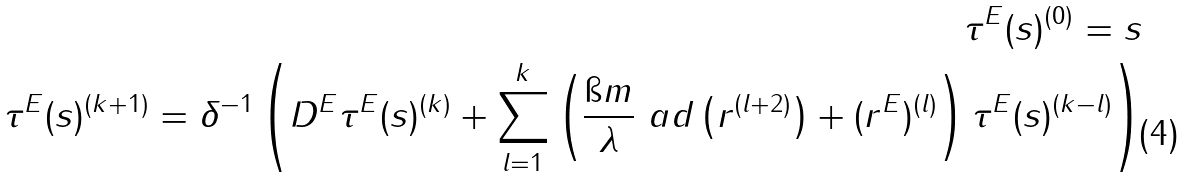<formula> <loc_0><loc_0><loc_500><loc_500>\tau ^ { E } ( s ) ^ { ( 0 ) } = s \\ \tau ^ { E } ( s ) ^ { ( k + 1 ) } = \delta ^ { - 1 } \left ( D ^ { E } \tau ^ { E } ( s ) ^ { ( k ) } + \sum _ { l = 1 } ^ { k } \left ( \frac { \i m } { \lambda } \ a d \left ( r ^ { ( l + 2 ) } \right ) + ( r ^ { E } ) ^ { ( l ) } \right ) \tau ^ { E } ( s ) ^ { ( k - l ) } \right )</formula> 